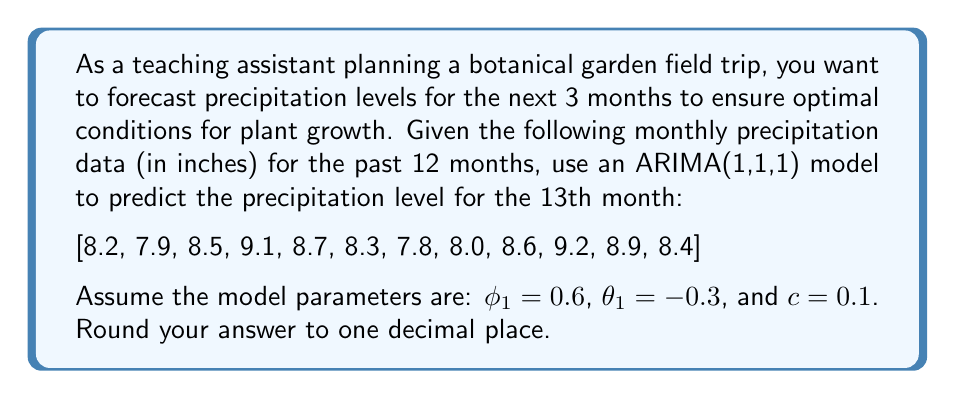Provide a solution to this math problem. To forecast precipitation levels using an ARIMA(1,1,1) model, we'll follow these steps:

1) First, we need to difference the series once to make it stationary. Let $y_t$ be the differenced series:

   $y_t = x_t - x_{t-1}$

   The differenced series is:
   [-0.3, 0.6, 0.6, -0.4, -0.4, -0.5, 0.2, 0.6, 0.6, -0.3, -0.5]

2) The ARIMA(1,1,1) model for the differenced series is:

   $y_t = c + \phi_1 y_{t-1} + \epsilon_t + \theta_1 \epsilon_{t-1}$

3) To forecast $y_{13}$, we use the equation:

   $\hat{y}_{13} = c + \phi_1 y_{12} + \theta_1 \epsilon_{12}$

4) We need to calculate $y_{12}$ and estimate $\epsilon_{12}$:
   
   $y_{12} = x_{12} - x_{11} = 8.4 - 8.9 = -0.5$

   $\epsilon_{12}$ can be estimated as the difference between the observed and predicted value for $y_{12}$:

   $\epsilon_{12} = y_{12} - (c + \phi_1 y_{11} + \theta_1 \epsilon_{11})$

   We don't have $\epsilon_{11}$, so we'll assume it's 0 for simplicity.

   $\epsilon_{12} = -0.5 - (0.1 + 0.6 \cdot (-0.3) + -0.3 \cdot 0) = -0.32$

5) Now we can forecast $y_{13}$:

   $\hat{y}_{13} = 0.1 + 0.6 \cdot (-0.5) + (-0.3) \cdot (-0.32) = -0.104$

6) To get the forecast for $x_{13}$, we need to "undifference" the series:

   $\hat{x}_{13} = x_{12} + \hat{y}_{13} = 8.4 + (-0.104) = 8.296$

7) Rounding to one decimal place, we get 8.3 inches.
Answer: 8.3 inches 